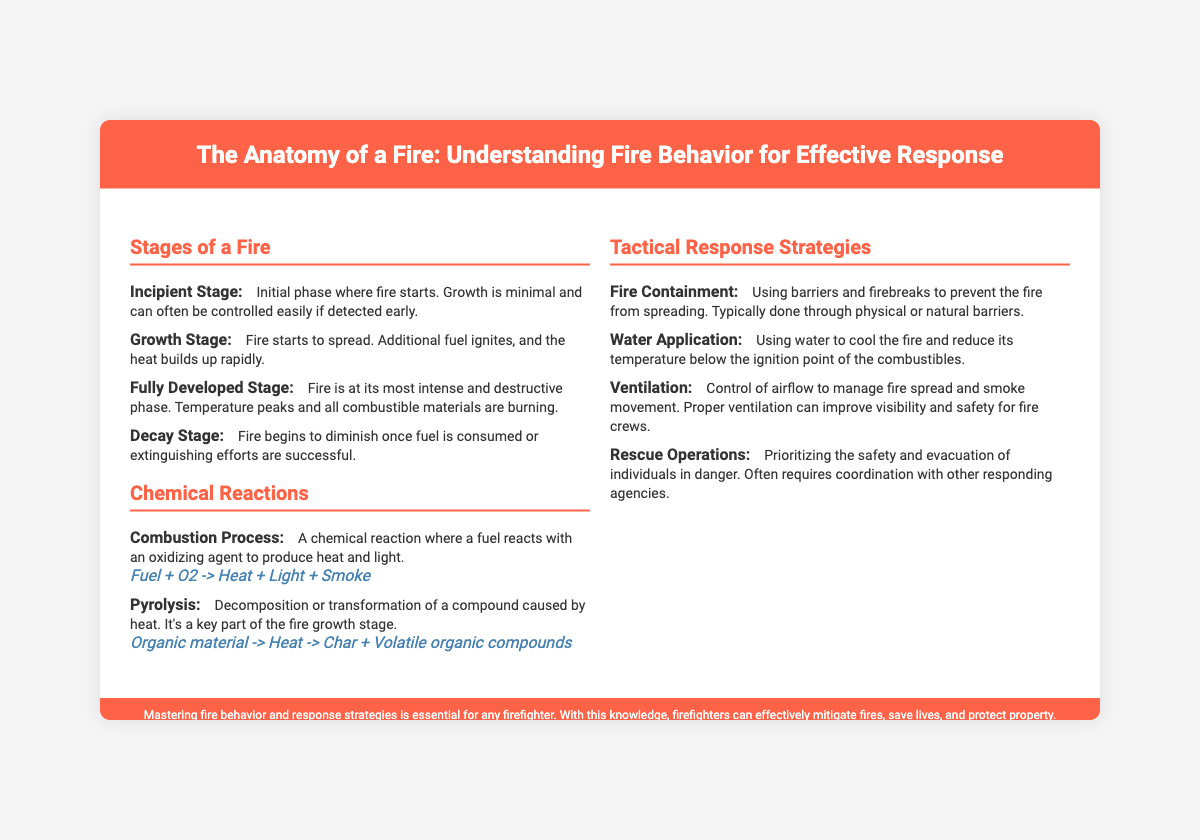What are the stages of a fire? The document outlines four stages of a fire: Incipient Stage, Growth Stage, Fully Developed Stage, and Decay Stage.
Answer: Incipient Stage, Growth Stage, Fully Developed Stage, Decay Stage What happens in the Fully Developed Stage? This stage is described as the phase when the fire is at its most intense and destructive.
Answer: Most intense and destructive What is the equation for the combustion process? The document provides the equation describing the combustion process: Fuel + O2 -> Heat + Light + Smoke.
Answer: Fuel + O2 -> Heat + Light + Smoke Which strategy utilizes barriers to prevent fire spread? The document specifies that Fire Containment involves using barriers and firebreaks for this purpose.
Answer: Fire Containment What is Pyrolysis? This term refers to the decomposition or transformation of a compound caused by heat, important during the fire growth stage.
Answer: Decomposition or transformation caused by heat How many tactical response strategies are listed in the document? The document provides a total of four tactical response strategies.
Answer: Four What is the main focus of Rescue Operations? According to the document, the primary focus is on the safety and evacuation of individuals in danger.
Answer: Safety and evacuation What is a key aspect of ventilation in firefighting? The document highlights that ventilation helps manage fire spread and smoke movement.
Answer: Manage fire spread and smoke movement What type of presentation is this document classified as? The content structure and focus indicate that this is a presentation slide.
Answer: Presentation slide 